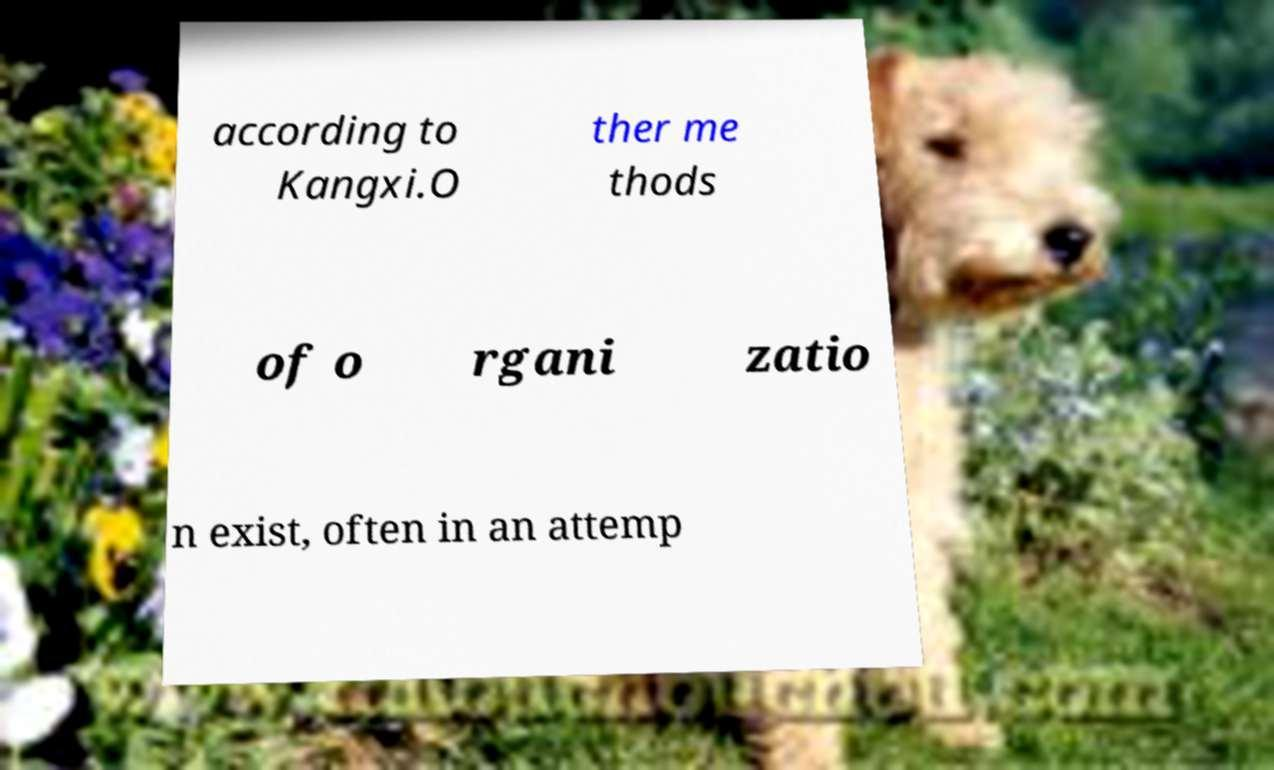Can you read and provide the text displayed in the image?This photo seems to have some interesting text. Can you extract and type it out for me? according to Kangxi.O ther me thods of o rgani zatio n exist, often in an attemp 